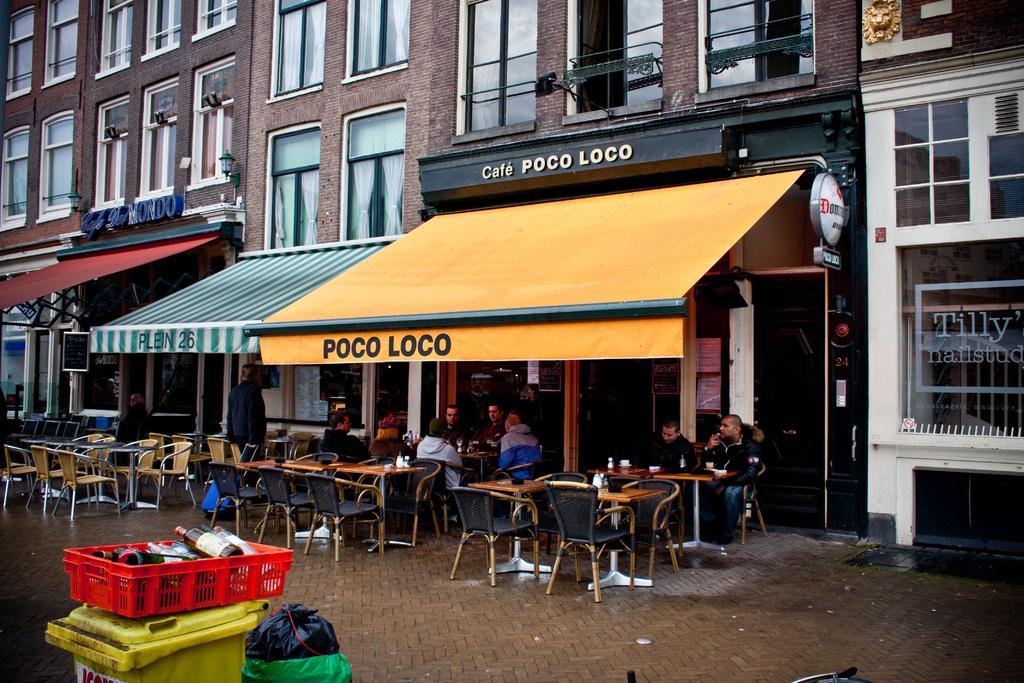Please provide a concise description of this image. There are tables and chairs. On the chairs there are few people sitting. Behind them there is a store. There is a building with many window and curtains. To the bottom there is a dustbin. On the dustbin there is a basket with bottles in it. 